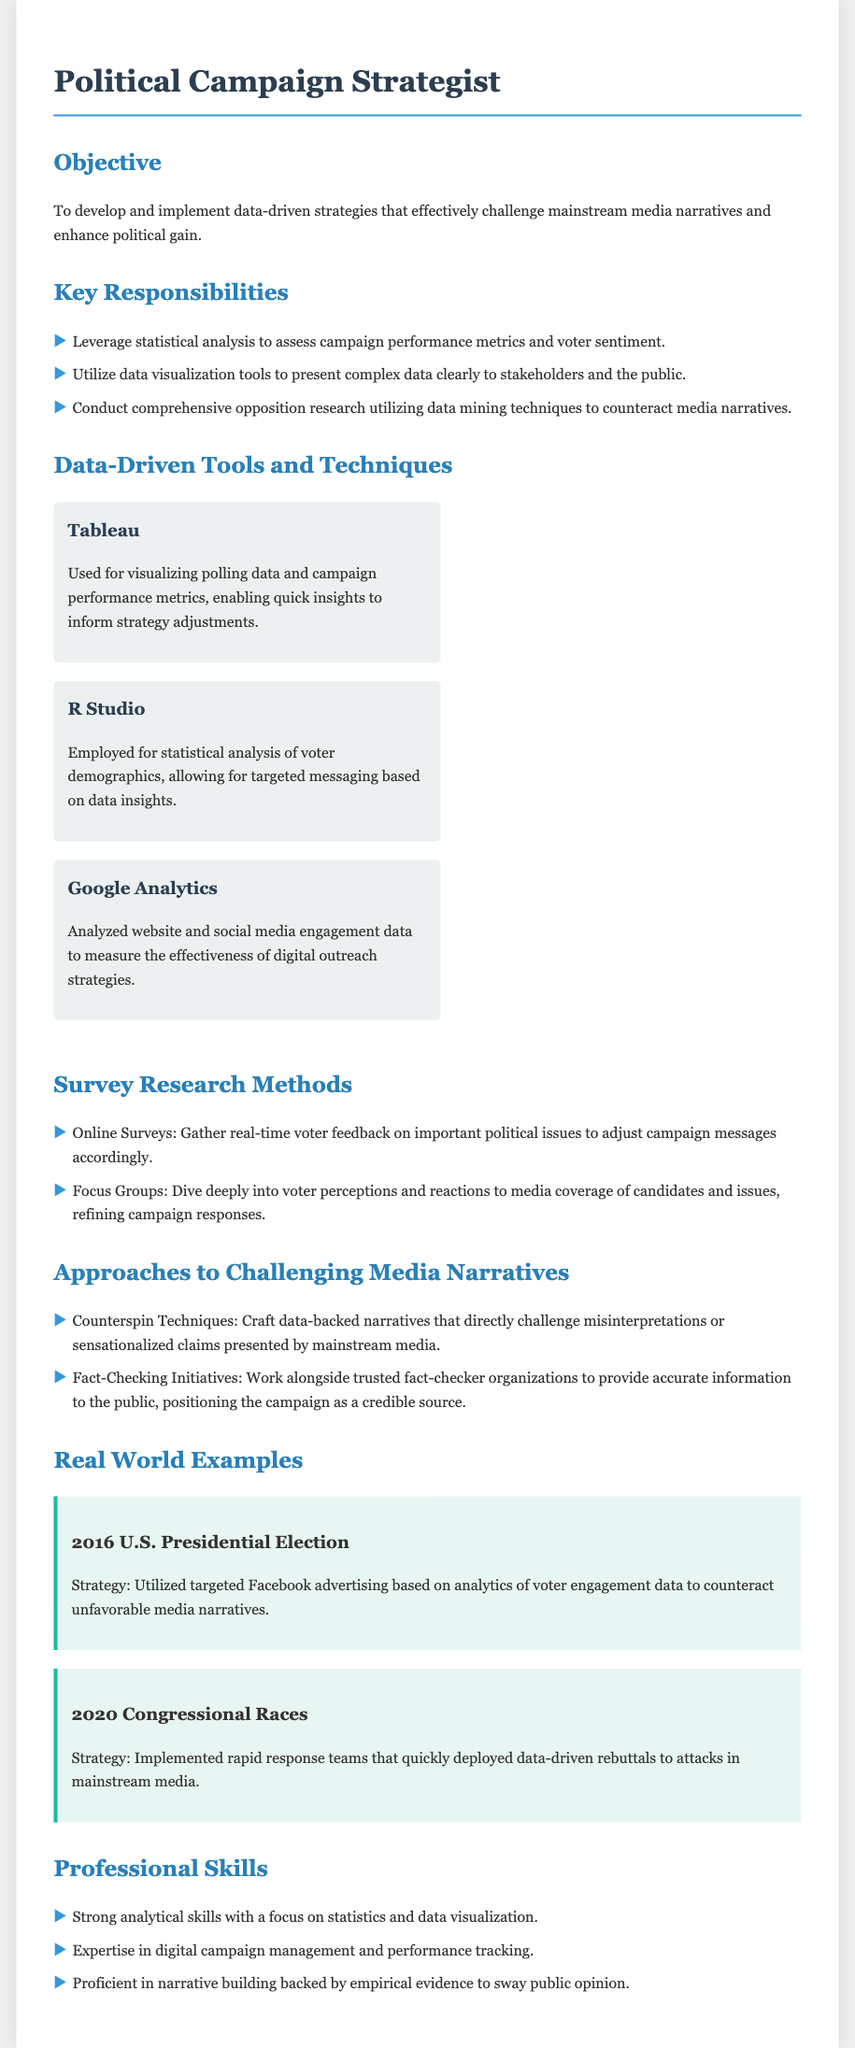what is the title of the document? The title of the document is indicated in the <title> tag of the HTML code.
Answer: Political Campaign Strategist CV what tool is used for visualizing polling data? The document lists tools used for data-driven decision-making in campaign strategies, and Tableau is specifically mentioned for this purpose.
Answer: Tableau how many professional skills are listed in the document? The document lists specific skills under the Professional Skills section, which can be counted directly from the bulleted points.
Answer: Three which survey method involves gathering real-time voter feedback? The document describes survey research methods, and Online Surveys is specifically mentioned as a way to gather this feedback.
Answer: Online Surveys what statistical tool is employed for analyzing voter demographics? The document states R Studio is used as a statistical tool for understanding voter demographics.
Answer: R Studio in which election was targeted Facebook advertising utilized? The document provides a real-world example and details the strategy used during the 2016 U.S. Presidential Election.
Answer: 2016 U.S. Presidential Election what is the strategy for the 2020 Congressional Races? The document mentions that the strategy involved implementing rapid response teams for rebuttals to media attacks.
Answer: Rapid response teams how does the document suggest challenging misinterpretations by the media? The document outlines that Counterspin Techniques can be used to create narratives which directly confront media misinterpretations.
Answer: Counterspin Techniques what is the main objective of the political campaign strategist as stated in the document? The objective is clearly outlined at the beginning of the document, focusing on data-driven strategies to challenge media narratives.
Answer: Data-driven strategies 